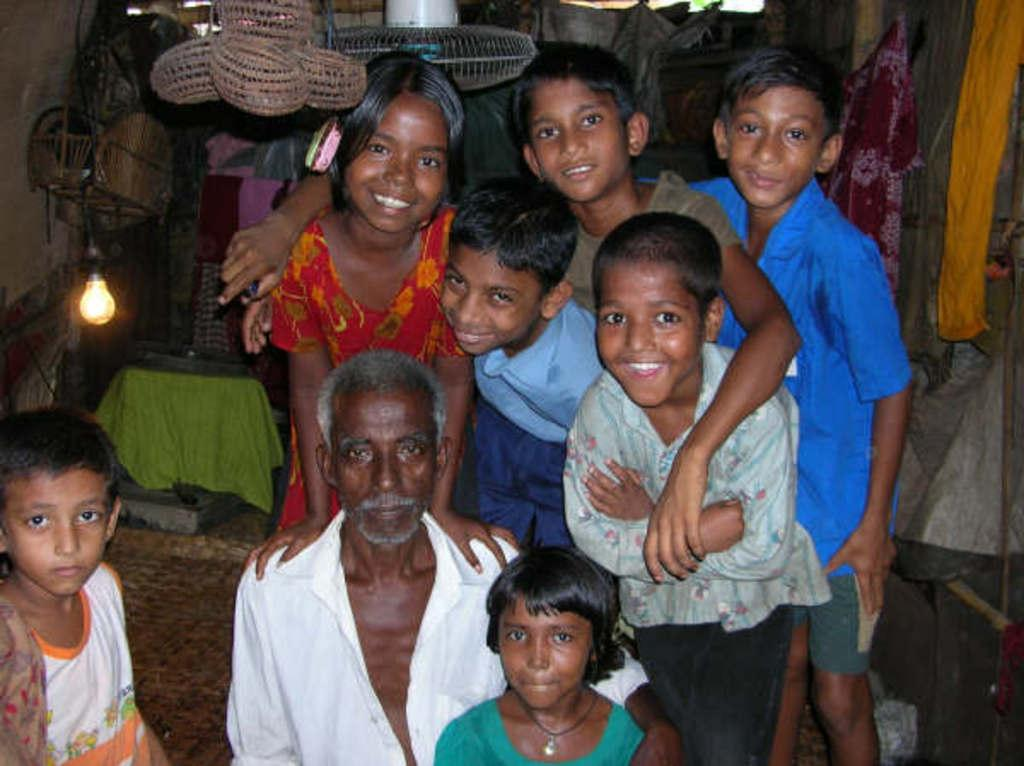What is the main subject of the image? The main subject of the image is a group of children. Can you describe the clothing of one of the children? One person is wearing a white shirt. What objects can be seen in the background of the image? There are baskets, a bulb, and a fan in the background of the image. How many deer are present in the image? There are no deer present in the image; it features a group of children and objects in the background. What type of club is being used by the children in the image? There is no club present in the image; the children are not depicted using any sports equipment or tools. 